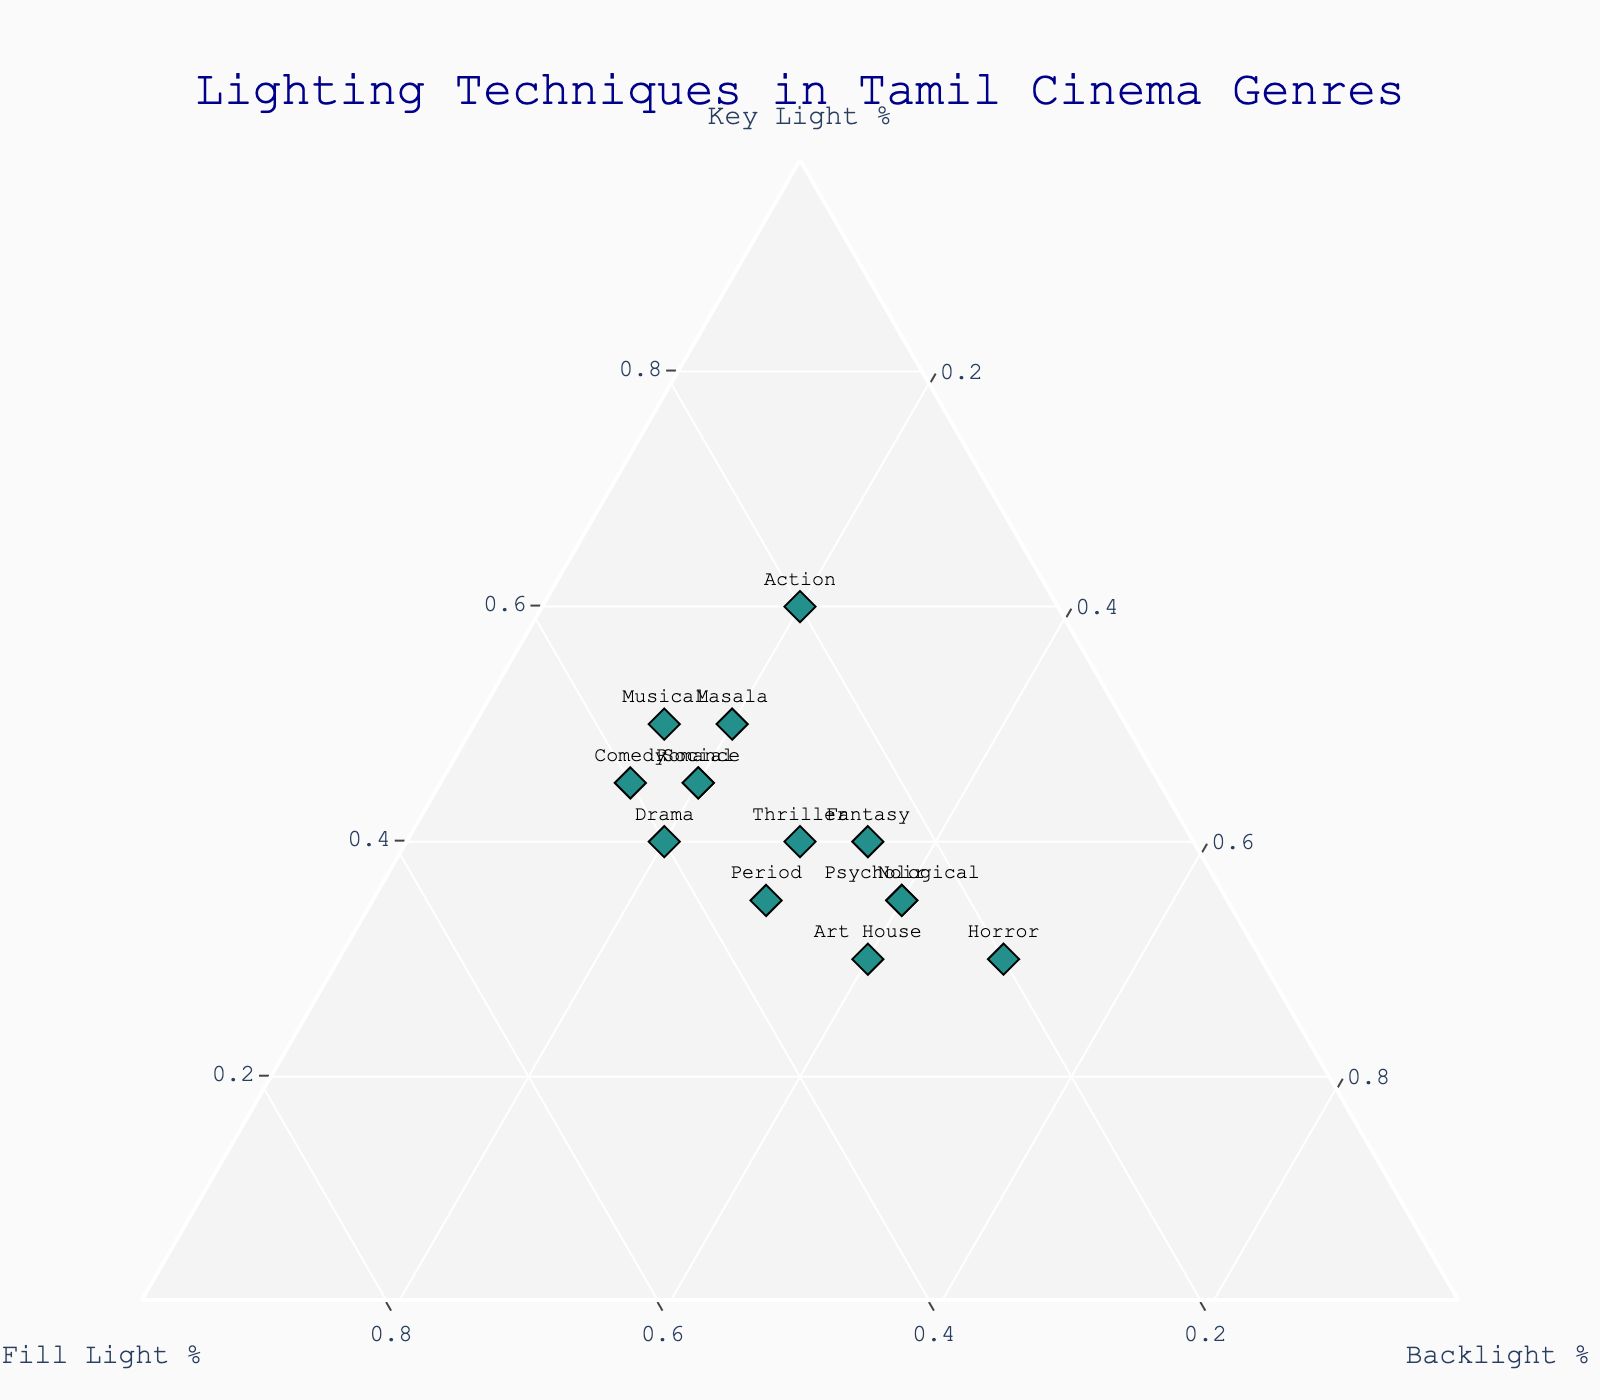What's the title of the plot? The title is displayed at the center-top of the figure. It reads "Lighting Techniques in Tamil Cinema Genres."
Answer: Lighting Techniques in Tamil Cinema Genres Which genre has the highest percentage of backlight usage? By looking at the 'Backlight %' axis and observing the markers' positions along the axis that represents backlight usage, we can determine that the 'Horror' genre has the highest percentage of backlight usage, shown by its position farthest along the 'Backlight %' side of the ternary plot.
Answer: Horror Which genres have a higher percentage of key light compared to fill light? Observing the 'Key Light %' and 'Fill Light %' axes, genres such as 'Masala,' 'Action,' 'Romance,' 'Comedy,' 'Musical,' and 'Social' have their markers positioned more towards the 'Key Light %' axis than towards the 'Fill Light %' axis.
Answer: Masala, Action, Romance, Comedy, Musical, Social What percentage of fill light is used in the Drama genre? By locating the 'Drama' genre marker and referring to its fill light percentage on the ternary plot, it is observed that the 'Drama' genre has 40% fill light.
Answer: 40% Which genres use equal percentages of key and fill light? By examining the markers on the plot, the genres where markers fall along the line representing equal key and fill light percentages are 'Drama' and 'Period,' both of which use the same proportion of key and fill light.
Answer: Drama, Period What is the most balanced use of all three lighting techniques? The most balanced genre would have all three lighting percentages as close as possible. By examining the plot, 'Period' and 'Thriller' genres show a relatively balanced use of key, fill, and backlight.
Answer: Period, Thriller Which genre uses the least fill light? Observing the plot along the 'Fill Light %' axis, the genre with the marker placed closest to the minimum fill light percentage is 'Horror' with 20%.
Answer: Horror How does the lighting composition of 'Noir' compare to that of 'Fantasy'? By observing the respective markers, 'Noir' uses 35% key light, 25% fill light, and 40% backlight, while 'Fantasy' uses 40% key light, 25% fill light, and 35% backlight. Thus, 'Noir' has slightly less key light and slightly more backlight than 'Fantasy,' while the fill light stays the same.
Answer: Noir has slightly less key light and more backlight than Fantasy How does the action genre differ in lighting technique from the masala genre? The 'Action' genre uses 60% key light, 20% fill light, and 20% backlight, while the 'Masala' genre uses 50% key light, 30% fill light, and 20% backlight. These indicate that 'Action' uses more key light and less fill light compared to 'Masala' while the backlight usage is the same for both.
Answer: Action uses more key light and less fill light than Masala 